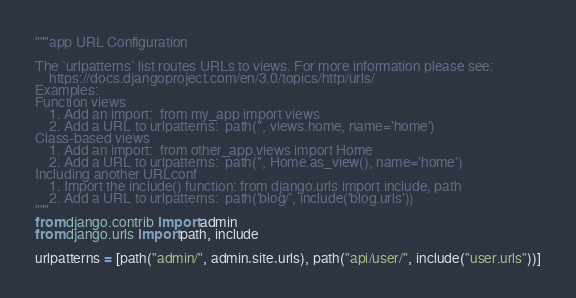<code> <loc_0><loc_0><loc_500><loc_500><_Python_>"""app URL Configuration

The `urlpatterns` list routes URLs to views. For more information please see:
    https://docs.djangoproject.com/en/3.0/topics/http/urls/
Examples:
Function views
    1. Add an import:  from my_app import views
    2. Add a URL to urlpatterns:  path('', views.home, name='home')
Class-based views
    1. Add an import:  from other_app.views import Home
    2. Add a URL to urlpatterns:  path('', Home.as_view(), name='home')
Including another URLconf
    1. Import the include() function: from django.urls import include, path
    2. Add a URL to urlpatterns:  path('blog/', include('blog.urls'))
"""
from django.contrib import admin
from django.urls import path, include

urlpatterns = [path("admin/", admin.site.urls), path("api/user/", include("user.urls"))]
</code> 